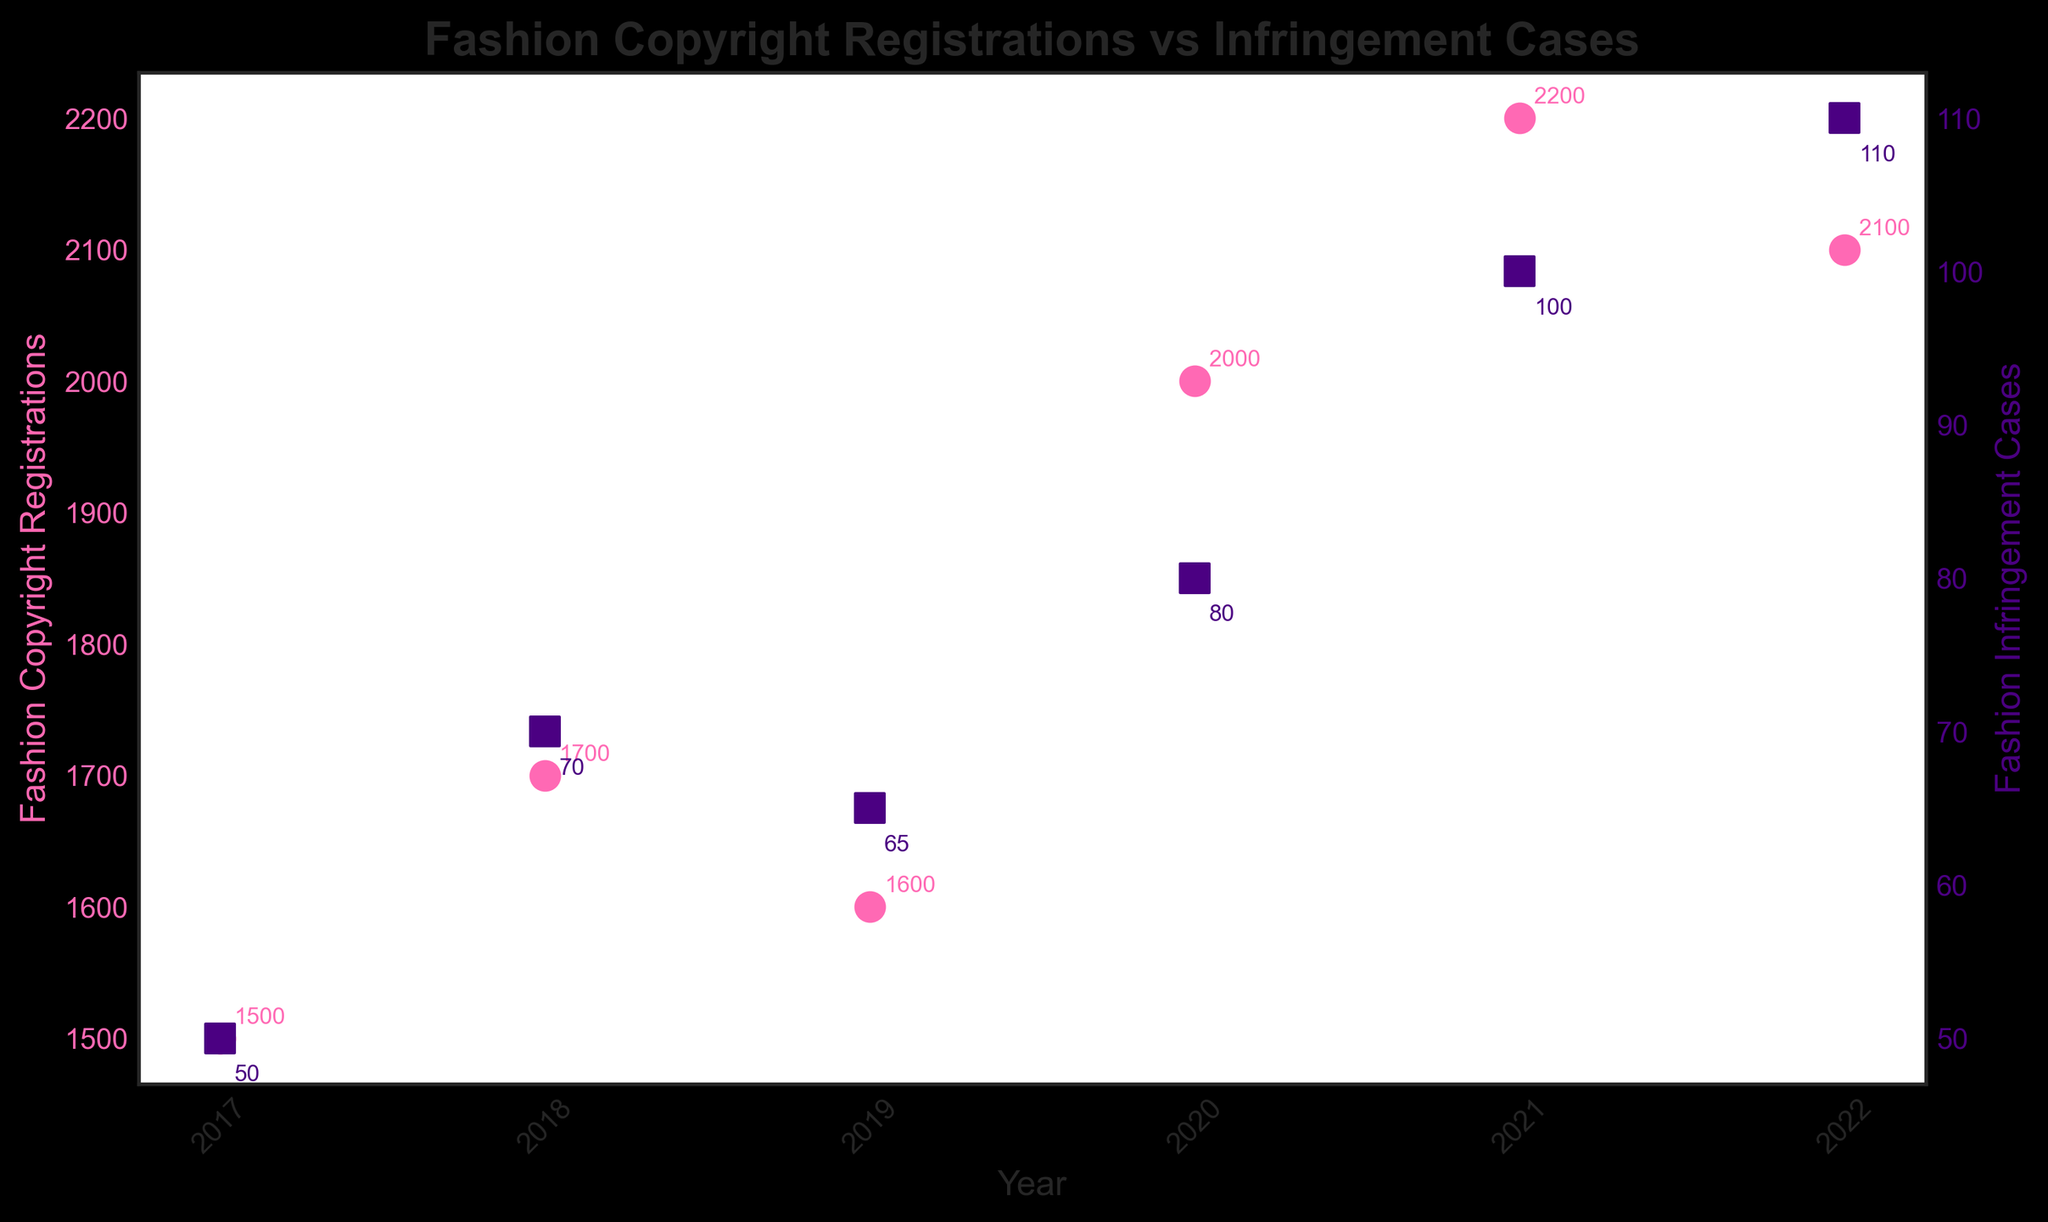What's the title of the plot? The title is typically placed at the top of the plot. From the provided code, we can see that the title of the plot is set to 'Fashion Copyright Registrations vs Infringement Cases'.
Answer: Fashion Copyright Registrations vs Infringement Cases What color represents Fashion Copyright Registrations in the plot? The color representing the Fashion Copyright Registrations is set to pink ('#FF69B4'). This is visible through the pink circles used in the plot.
Answer: Pink How many years are shown in the plot? The x-axis (Years) has several ticks, each corresponding to a year from the provided data. By counting these ticks, we can determine that the plot shows 6 years.
Answer: 6 Which year had the highest number of Fashion Infringement Cases? By examining the scatter plot and identifying the highest point on the y-axis corresponding to Fashion Infringement Cases, we see that the highest value occurs in the year 2022, with 110 cases.
Answer: 2022 What is the difference in Fashion Copyright Registrations between 2021 and 2022? By looking at the y-axis values for Fashion Copyright Registrations for the years 2021 and 2022, we see 2200 for 2021 and 2100 for 2022. The difference is calculated as 2200 - 2100.
Answer: 100 What is the average number of Fashion Infringement Cases from 2017 to 2022? Summing all the Fashion Infringement Cases from 2017 to 2022: 50 + 70 + 65 + 80 + 100 + 110 = 475. Then, dividing by the number of years (6), we get 475 / 6 ≈ 79.17.
Answer: 79.17 In which year did both Fashion Copyright Registrations and Infringement Cases increase compared to the previous year? By examining the data points across the plot, we see increases in both registrations and infringement cases from 2017 to 2018, and then again from 2019 to 2020, and from 2020 to 2021. For the clearest example, in 2020, registrations increased from 1600 to 2000, and cases from 65 to 80.
Answer: 2020 What's the range of Fashion Copyright Registrations over the years? The range is determined by the difference between the maximum and minimum registrations. The minimum is 1500 in 2017, and the maximum is 2200 in 2021. Therefore, the range is 2200 - 1500.
Answer: 700 Are there more Fashion Copyright Registrations or Fashion Infringement Cases in 2018? By checking the y-axis values for both datasets in 2018, we see that there are 1700 registrations and 70 infringement cases. Since 1700 is greater than 70, there are more registrations.
Answer: Fashion Copyright Registrations Which year saw the smallest increase in Fashion Copyright Registrations compared to the previous year? To find the year with the smallest increase, observe the differences. The smallest increment is from 2021 to 2022, which is 2200 - 2100. This increment of 100 is less than other years.
Answer: 2022 